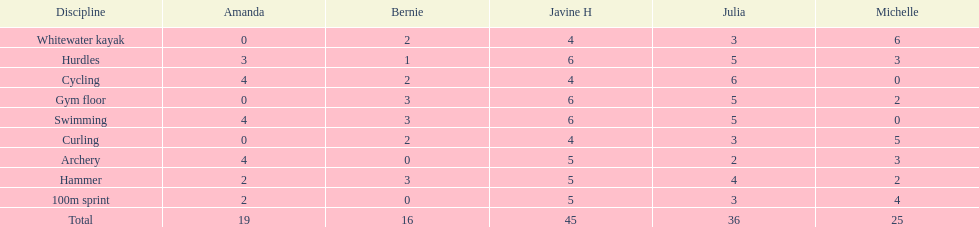Could you help me parse every detail presented in this table? {'header': ['Discipline', 'Amanda', 'Bernie', 'Javine H', 'Julia', 'Michelle'], 'rows': [['Whitewater kayak', '0', '2', '4', '3', '6'], ['Hurdles', '3', '1', '6', '5', '3'], ['Cycling', '4', '2', '4', '6', '0'], ['Gym floor', '0', '3', '6', '5', '2'], ['Swimming', '4', '3', '6', '5', '0'], ['Curling', '0', '2', '4', '3', '5'], ['Archery', '4', '0', '5', '2', '3'], ['Hammer', '2', '3', '5', '4', '2'], ['100m sprint', '2', '0', '5', '3', '4'], ['Total', '19', '16', '45', '36', '25']]} Who had the least points in the whitewater kayak event? Amanda. 